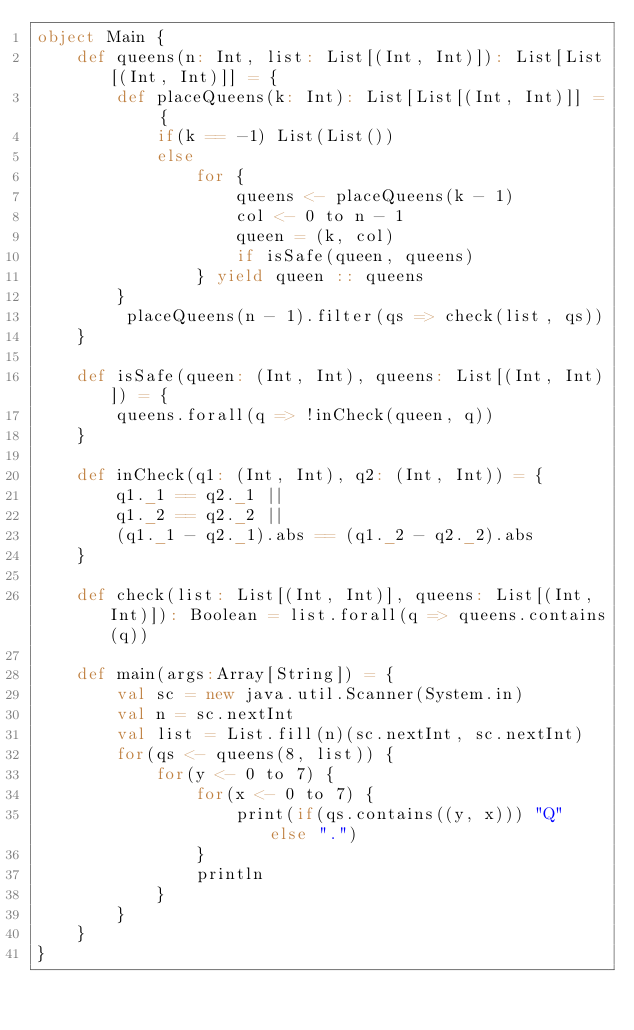<code> <loc_0><loc_0><loc_500><loc_500><_Scala_>object Main {
    def queens(n: Int, list: List[(Int, Int)]): List[List[(Int, Int)]] = {
        def placeQueens(k: Int): List[List[(Int, Int)]] = {
            if(k == -1) List(List())
            else
                for {
                    queens <- placeQueens(k - 1)
                    col <- 0 to n - 1
                    queen = (k, col)
                    if isSafe(queen, queens)
                } yield queen :: queens
        }
         placeQueens(n - 1).filter(qs => check(list, qs))
    }

    def isSafe(queen: (Int, Int), queens: List[(Int, Int)]) = {
        queens.forall(q => !inCheck(queen, q))
    }

    def inCheck(q1: (Int, Int), q2: (Int, Int)) = {
        q1._1 == q2._1 ||
        q1._2 == q2._2 ||
        (q1._1 - q2._1).abs == (q1._2 - q2._2).abs
    }

    def check(list: List[(Int, Int)], queens: List[(Int, Int)]): Boolean = list.forall(q => queens.contains(q))

    def main(args:Array[String]) = {
        val sc = new java.util.Scanner(System.in)
        val n = sc.nextInt
        val list = List.fill(n)(sc.nextInt, sc.nextInt)
        for(qs <- queens(8, list)) {
            for(y <- 0 to 7) {
                for(x <- 0 to 7) {
                    print(if(qs.contains((y, x))) "Q" else ".")
                }
                println
            }
        }
    }
}</code> 